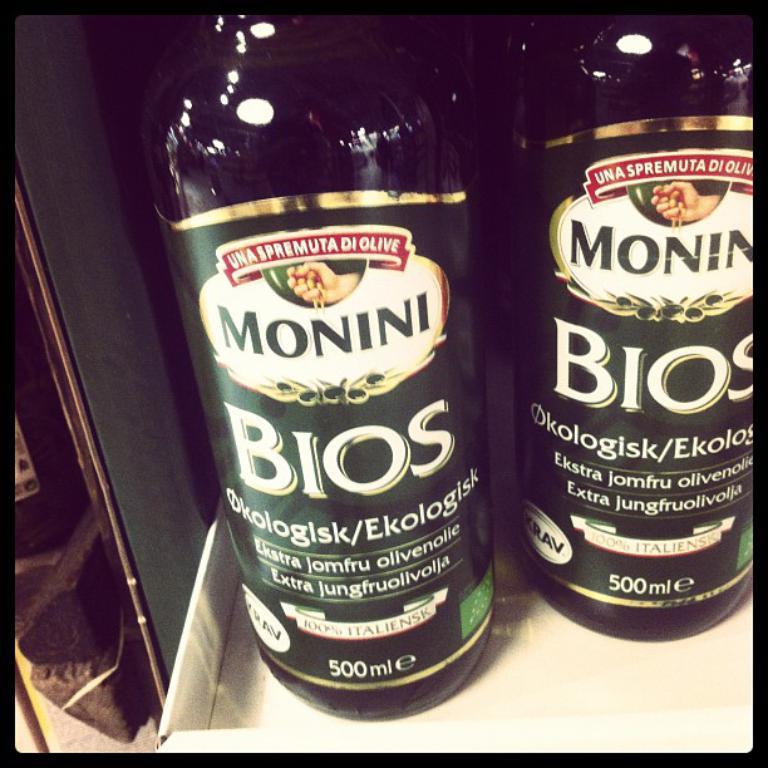What is the volume of the liquid in the bottle?
Keep it short and to the point. 500 ml. Who is the maker of this bottle?
Provide a short and direct response. Monini. 